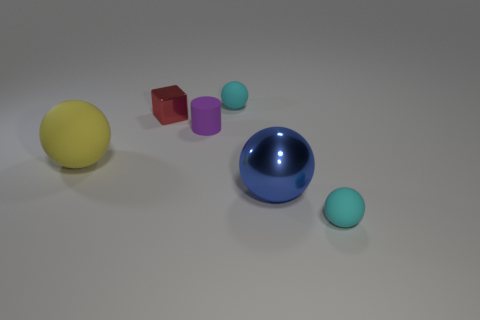Do the tiny shiny thing and the big thing on the left side of the small matte cylinder have the same shape?
Offer a very short reply. No. How big is the purple cylinder?
Offer a terse response. Small. Is the number of rubber spheres right of the cube less than the number of matte balls?
Offer a terse response. Yes. What number of yellow rubber blocks are the same size as the blue metallic thing?
Offer a terse response. 0. There is a tiny matte ball that is behind the big matte thing; is it the same color as the tiny ball in front of the red cube?
Ensure brevity in your answer.  Yes. How many cyan matte things are behind the large blue sphere?
Provide a short and direct response. 1. Is there another big thing that has the same shape as the blue metallic object?
Ensure brevity in your answer.  Yes. There is another shiny object that is the same size as the yellow object; what is its color?
Offer a terse response. Blue. Is the number of tiny purple cylinders behind the red shiny cube less than the number of cyan things that are behind the tiny cylinder?
Give a very brief answer. Yes. There is a rubber thing behind the purple cylinder; is its size the same as the tiny metal cube?
Provide a short and direct response. Yes. 